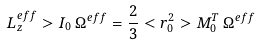Convert formula to latex. <formula><loc_0><loc_0><loc_500><loc_500>L ^ { e f f } _ { z } > I _ { 0 } \, \Omega ^ { e f f } = \frac { 2 } { 3 } < r ^ { 2 } _ { 0 } > M _ { 0 } ^ { T } \, \Omega ^ { e f f }</formula> 